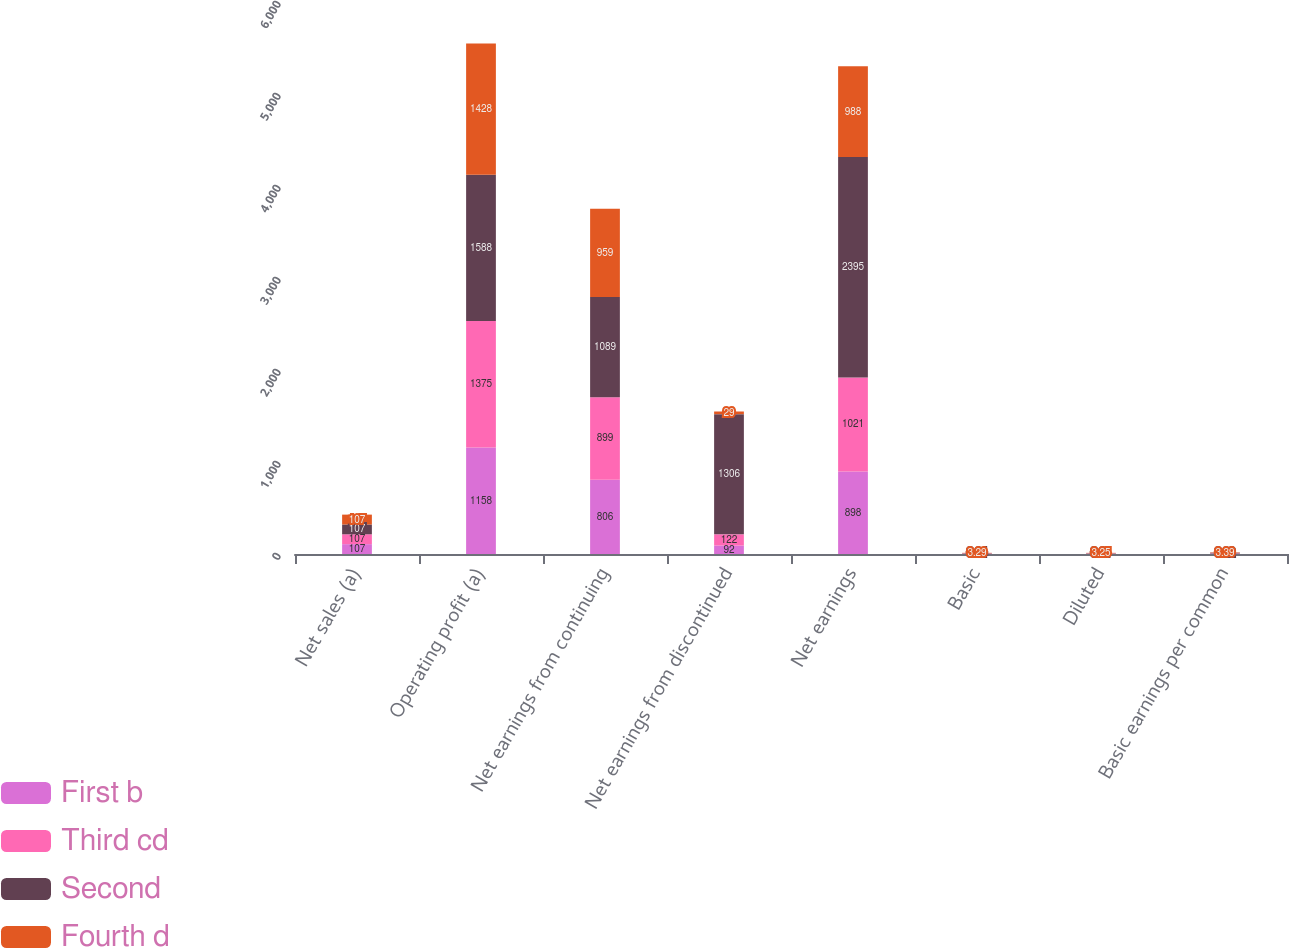Convert chart. <chart><loc_0><loc_0><loc_500><loc_500><stacked_bar_chart><ecel><fcel>Net sales (a)<fcel>Operating profit (a)<fcel>Net earnings from continuing<fcel>Net earnings from discontinued<fcel>Net earnings<fcel>Basic<fcel>Diluted<fcel>Basic earnings per common<nl><fcel>First b<fcel>107<fcel>1158<fcel>806<fcel>92<fcel>898<fcel>2.65<fcel>2.61<fcel>2.95<nl><fcel>Third cd<fcel>107<fcel>1375<fcel>899<fcel>122<fcel>1021<fcel>2.97<fcel>2.93<fcel>3.37<nl><fcel>Second<fcel>107<fcel>1588<fcel>1089<fcel>1306<fcel>2395<fcel>3.64<fcel>3.61<fcel>8.02<nl><fcel>Fourth d<fcel>107<fcel>1428<fcel>959<fcel>29<fcel>988<fcel>3.29<fcel>3.25<fcel>3.39<nl></chart> 